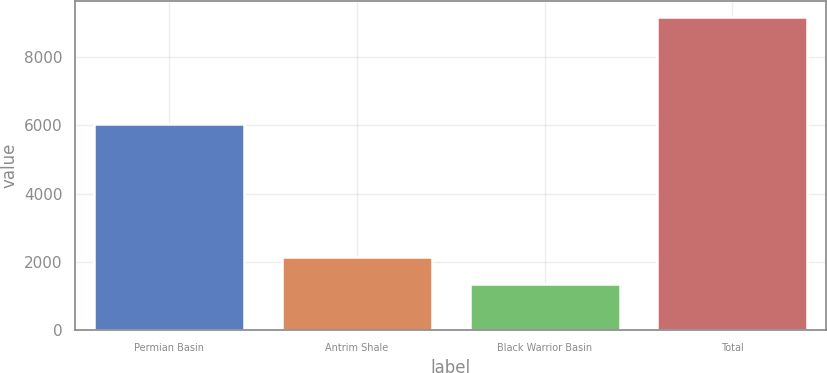<chart> <loc_0><loc_0><loc_500><loc_500><bar_chart><fcel>Permian Basin<fcel>Antrim Shale<fcel>Black Warrior Basin<fcel>Total<nl><fcel>6022<fcel>2131.8<fcel>1349<fcel>9177<nl></chart> 